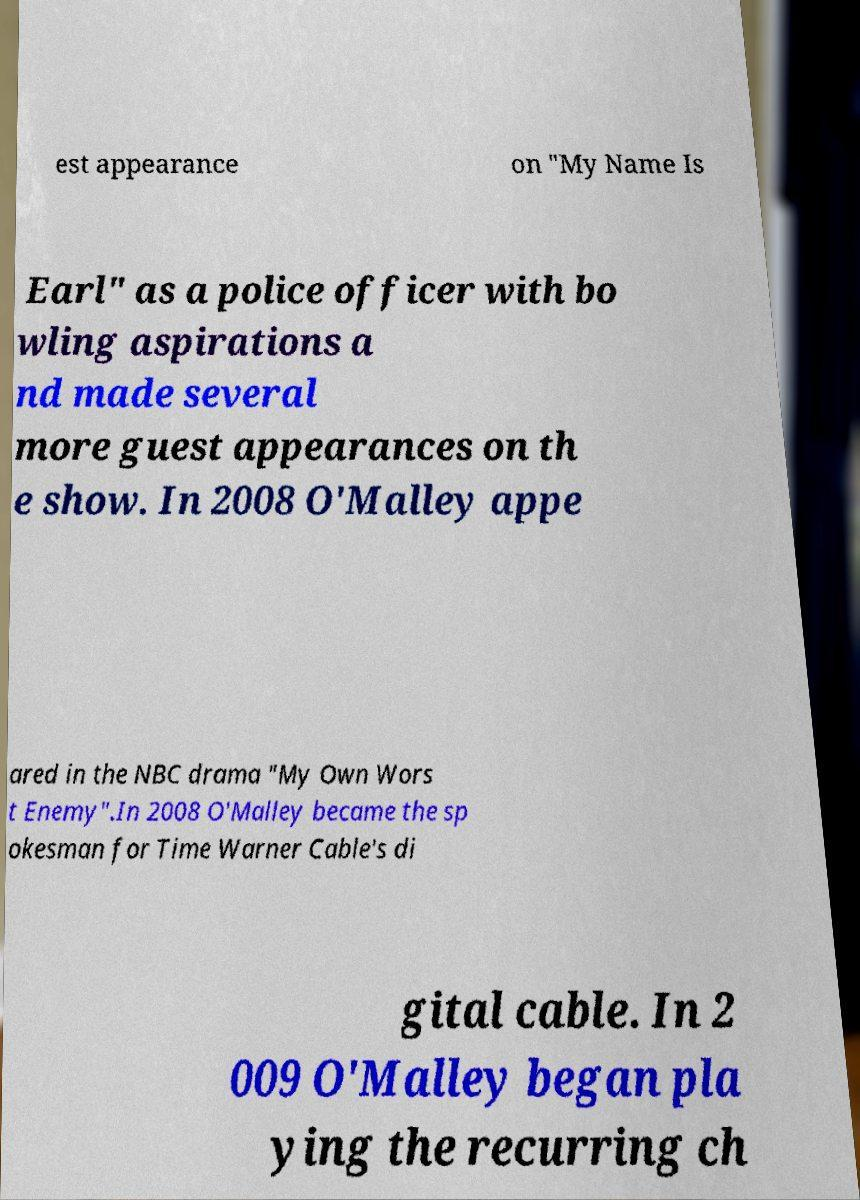There's text embedded in this image that I need extracted. Can you transcribe it verbatim? est appearance on "My Name Is Earl" as a police officer with bo wling aspirations a nd made several more guest appearances on th e show. In 2008 O'Malley appe ared in the NBC drama "My Own Wors t Enemy".In 2008 O'Malley became the sp okesman for Time Warner Cable's di gital cable. In 2 009 O'Malley began pla ying the recurring ch 